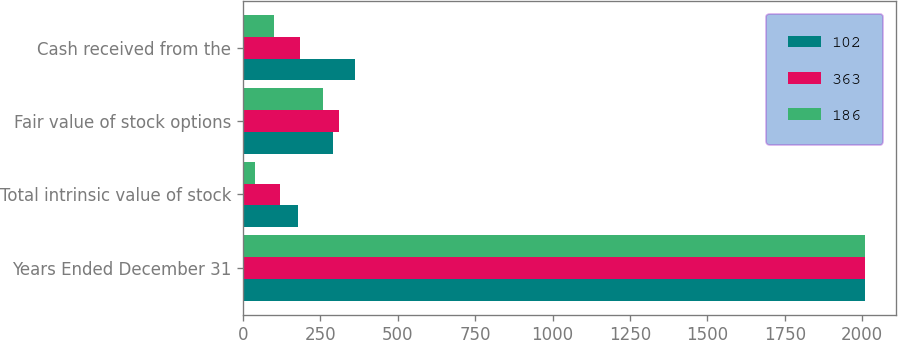Convert chart to OTSL. <chart><loc_0><loc_0><loc_500><loc_500><stacked_bar_chart><ecel><fcel>Years Ended December 31<fcel>Total intrinsic value of stock<fcel>Fair value of stock options<fcel>Cash received from the<nl><fcel>102<fcel>2010<fcel>177<fcel>290<fcel>363<nl><fcel>363<fcel>2009<fcel>119<fcel>311<fcel>186<nl><fcel>186<fcel>2008<fcel>40<fcel>259<fcel>102<nl></chart> 